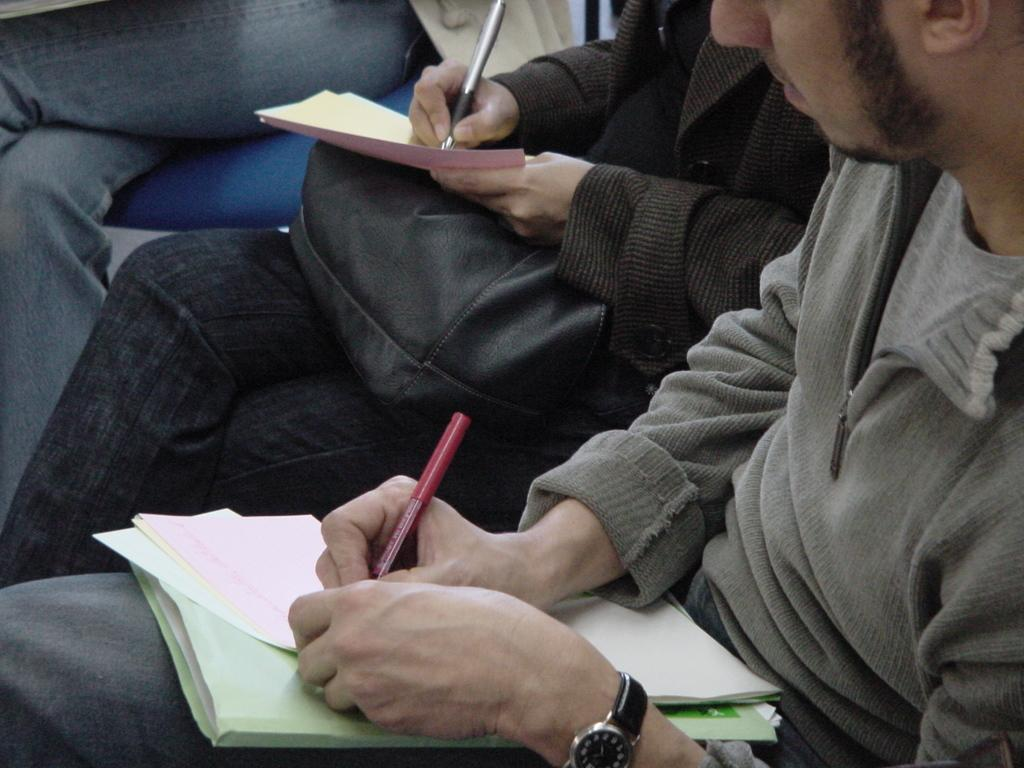What is the man in the image doing? The man is writing on a paper in the image. What is the woman in the image holding? The woman is holding a black color bag in the image. Can you describe the man's attire? The man is wearing a watch in the image. What is the woman's primary activity in the image? The woman is holding a black color bag in the image. Are there any visible details on the cobweb in the image? There is no cobweb present in the image. How does the man turn the paper while writing in the image? The man is not turning the paper while writing in the image; he is writing on a stationary piece of paper. 